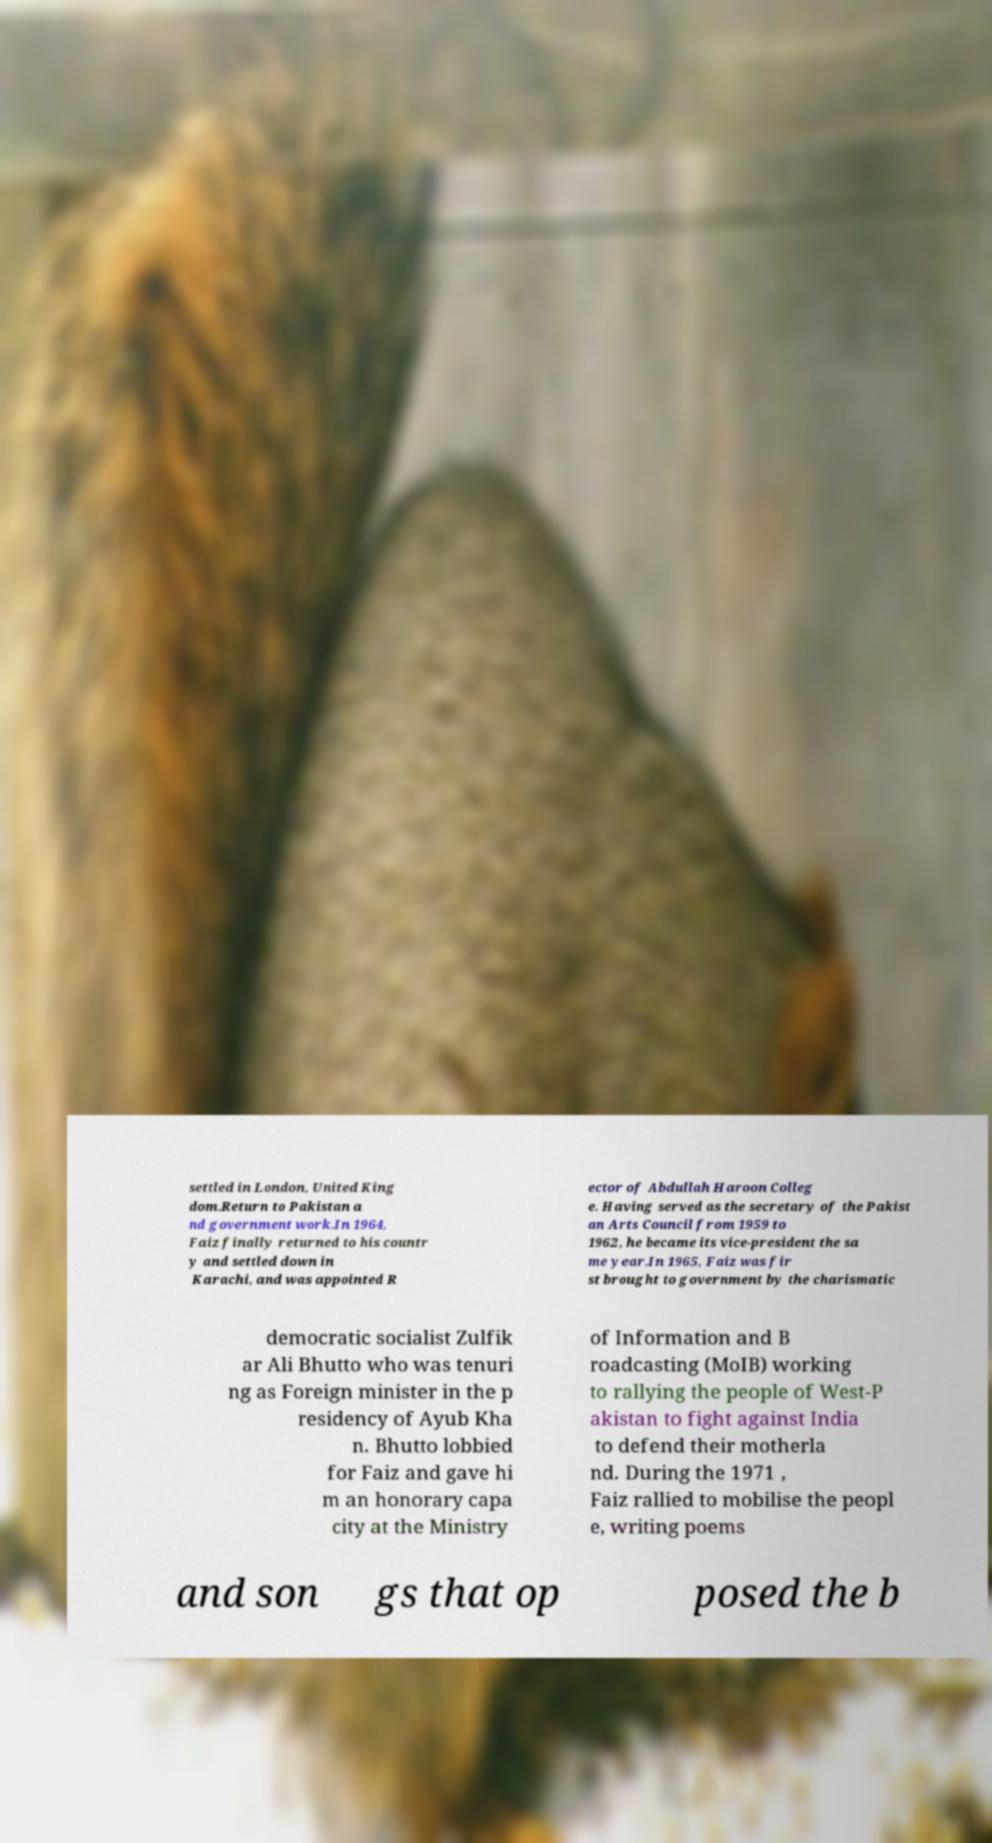Please read and relay the text visible in this image. What does it say? settled in London, United King dom.Return to Pakistan a nd government work.In 1964, Faiz finally returned to his countr y and settled down in Karachi, and was appointed R ector of Abdullah Haroon Colleg e. Having served as the secretary of the Pakist an Arts Council from 1959 to 1962, he became its vice-president the sa me year.In 1965, Faiz was fir st brought to government by the charismatic democratic socialist Zulfik ar Ali Bhutto who was tenuri ng as Foreign minister in the p residency of Ayub Kha n. Bhutto lobbied for Faiz and gave hi m an honorary capa city at the Ministry of Information and B roadcasting (MoIB) working to rallying the people of West-P akistan to fight against India to defend their motherla nd. During the 1971 , Faiz rallied to mobilise the peopl e, writing poems and son gs that op posed the b 